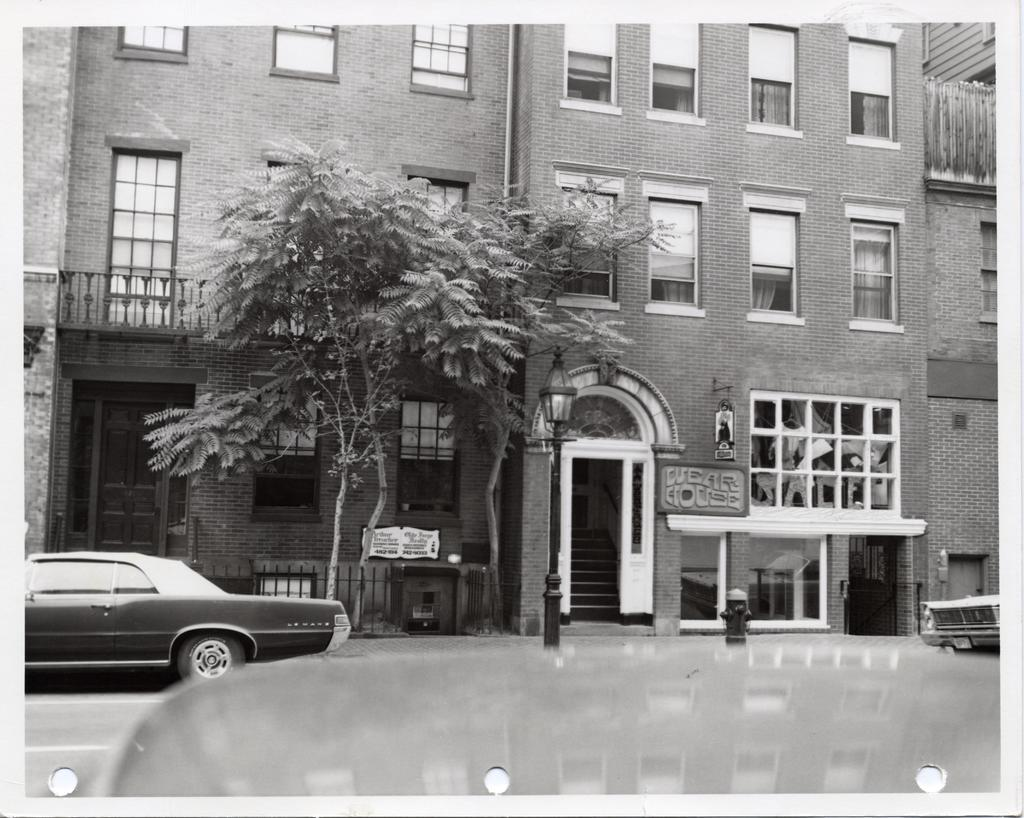What type of structures can be seen in the image? There are buildings in the image. What other natural elements are present in the image? There are trees in the image. What mode of transportation can be observed on the road in the image? Vehicles are visible on the road in the image. How is the image presented in terms of color? The image is black and white in color. What type of silk is draped over the branch in the image? There is no silk or branch present in the image. How many beams can be seen supporting the structure in the image? There is no beam present in the image; it only features buildings, trees, and vehicles. 